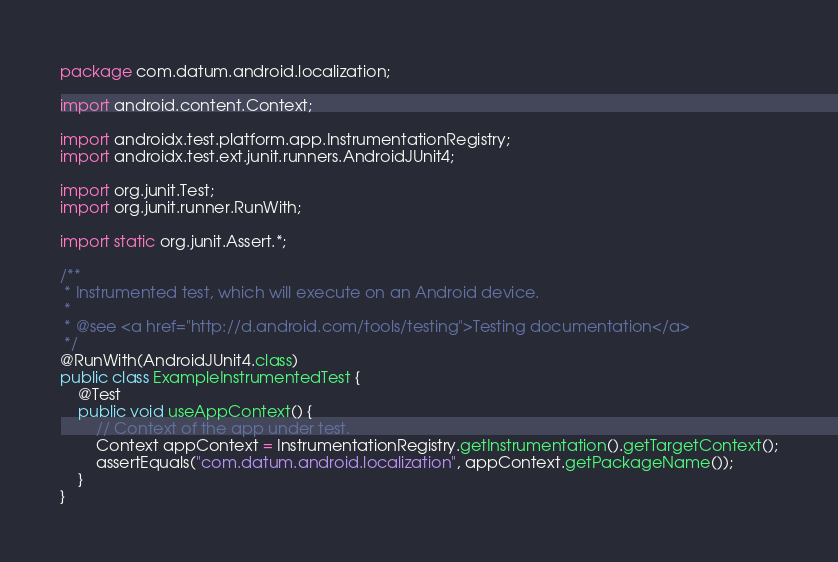<code> <loc_0><loc_0><loc_500><loc_500><_Java_>package com.datum.android.localization;

import android.content.Context;

import androidx.test.platform.app.InstrumentationRegistry;
import androidx.test.ext.junit.runners.AndroidJUnit4;

import org.junit.Test;
import org.junit.runner.RunWith;

import static org.junit.Assert.*;

/**
 * Instrumented test, which will execute on an Android device.
 *
 * @see <a href="http://d.android.com/tools/testing">Testing documentation</a>
 */
@RunWith(AndroidJUnit4.class)
public class ExampleInstrumentedTest {
    @Test
    public void useAppContext() {
        // Context of the app under test.
        Context appContext = InstrumentationRegistry.getInstrumentation().getTargetContext();
        assertEquals("com.datum.android.localization", appContext.getPackageName());
    }
}</code> 